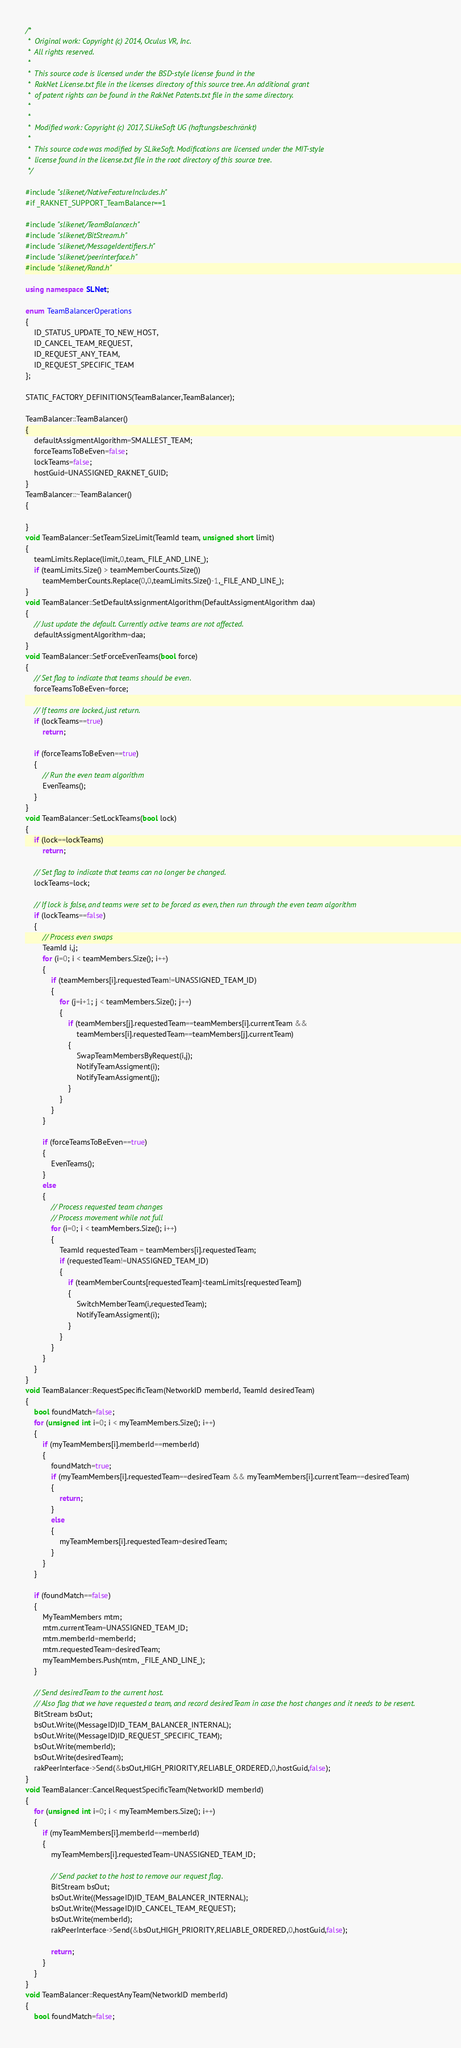<code> <loc_0><loc_0><loc_500><loc_500><_C++_>/*
 *  Original work: Copyright (c) 2014, Oculus VR, Inc.
 *  All rights reserved.
 *
 *  This source code is licensed under the BSD-style license found in the
 *  RakNet License.txt file in the licenses directory of this source tree. An additional grant 
 *  of patent rights can be found in the RakNet Patents.txt file in the same directory.
 *
 *
 *  Modified work: Copyright (c) 2017, SLikeSoft UG (haftungsbeschränkt)
 *
 *  This source code was modified by SLikeSoft. Modifications are licensed under the MIT-style
 *  license found in the license.txt file in the root directory of this source tree.
 */

#include "slikenet/NativeFeatureIncludes.h"
#if _RAKNET_SUPPORT_TeamBalancer==1

#include "slikenet/TeamBalancer.h"
#include "slikenet/BitStream.h"
#include "slikenet/MessageIdentifiers.h"
#include "slikenet/peerinterface.h"
#include "slikenet/Rand.h"

using namespace SLNet;

enum TeamBalancerOperations
{
	ID_STATUS_UPDATE_TO_NEW_HOST,
	ID_CANCEL_TEAM_REQUEST,
	ID_REQUEST_ANY_TEAM,
	ID_REQUEST_SPECIFIC_TEAM
};

STATIC_FACTORY_DEFINITIONS(TeamBalancer,TeamBalancer);

TeamBalancer::TeamBalancer()
{
	defaultAssigmentAlgorithm=SMALLEST_TEAM;
	forceTeamsToBeEven=false;
	lockTeams=false;
	hostGuid=UNASSIGNED_RAKNET_GUID;
}
TeamBalancer::~TeamBalancer()
{

}
void TeamBalancer::SetTeamSizeLimit(TeamId team, unsigned short limit)
{
	teamLimits.Replace(limit,0,team,_FILE_AND_LINE_);
	if (teamLimits.Size() > teamMemberCounts.Size())
		teamMemberCounts.Replace(0,0,teamLimits.Size()-1,_FILE_AND_LINE_);
}
void TeamBalancer::SetDefaultAssignmentAlgorithm(DefaultAssigmentAlgorithm daa)
{
	// Just update the default. Currently active teams are not affected.
	defaultAssigmentAlgorithm=daa;
}
void TeamBalancer::SetForceEvenTeams(bool force)
{
	// Set flag to indicate that teams should be even.
	forceTeamsToBeEven=force;

	// If teams are locked, just return.
	if (lockTeams==true)
		return;

	if (forceTeamsToBeEven==true)
	{
		// Run the even team algorithm
		EvenTeams();
	}
}
void TeamBalancer::SetLockTeams(bool lock)
{
	if (lock==lockTeams)
		return;

	// Set flag to indicate that teams can no longer be changed.
	lockTeams=lock;

	// If lock is false, and teams were set to be forced as even, then run through the even team algorithm
	if (lockTeams==false)
	{
		// Process even swaps
		TeamId i,j;
		for (i=0; i < teamMembers.Size(); i++)
		{
			if (teamMembers[i].requestedTeam!=UNASSIGNED_TEAM_ID)
			{
				for (j=i+1; j < teamMembers.Size(); j++)
				{
					if (teamMembers[j].requestedTeam==teamMembers[i].currentTeam &&
						teamMembers[i].requestedTeam==teamMembers[j].currentTeam)
					{
						SwapTeamMembersByRequest(i,j);
						NotifyTeamAssigment(i);
						NotifyTeamAssigment(j);
					}
				}
			}
		}

		if (forceTeamsToBeEven==true)
		{
			EvenTeams();
		}
		else
		{
			// Process requested team changes
			// Process movement while not full
			for (i=0; i < teamMembers.Size(); i++)
			{
				TeamId requestedTeam = teamMembers[i].requestedTeam;
				if (requestedTeam!=UNASSIGNED_TEAM_ID)
				{
					if (teamMemberCounts[requestedTeam]<teamLimits[requestedTeam])
					{
						SwitchMemberTeam(i,requestedTeam);
						NotifyTeamAssigment(i);
					}
				}
			}
		}
	}
}
void TeamBalancer::RequestSpecificTeam(NetworkID memberId, TeamId desiredTeam)
{
	bool foundMatch=false;
	for (unsigned int i=0; i < myTeamMembers.Size(); i++)
	{
		if (myTeamMembers[i].memberId==memberId)
		{
			foundMatch=true;
			if (myTeamMembers[i].requestedTeam==desiredTeam && myTeamMembers[i].currentTeam==desiredTeam)
			{
				return;
			}
			else
			{
				myTeamMembers[i].requestedTeam=desiredTeam;
			}
		}
	}

	if (foundMatch==false)
	{
		MyTeamMembers mtm;
		mtm.currentTeam=UNASSIGNED_TEAM_ID;
		mtm.memberId=memberId;
		mtm.requestedTeam=desiredTeam;
		myTeamMembers.Push(mtm, _FILE_AND_LINE_);
	}

	// Send desiredTeam to the current host.
	// Also flag that we have requested a team, and record desiredTeam in case the host changes and it needs to be resent.
	BitStream bsOut;
	bsOut.Write((MessageID)ID_TEAM_BALANCER_INTERNAL);
	bsOut.Write((MessageID)ID_REQUEST_SPECIFIC_TEAM);
	bsOut.Write(memberId);
	bsOut.Write(desiredTeam);
	rakPeerInterface->Send(&bsOut,HIGH_PRIORITY,RELIABLE_ORDERED,0,hostGuid,false);
}
void TeamBalancer::CancelRequestSpecificTeam(NetworkID memberId)
{
	for (unsigned int i=0; i < myTeamMembers.Size(); i++)
	{
		if (myTeamMembers[i].memberId==memberId)
		{
			myTeamMembers[i].requestedTeam=UNASSIGNED_TEAM_ID;

			// Send packet to the host to remove our request flag.
			BitStream bsOut;
			bsOut.Write((MessageID)ID_TEAM_BALANCER_INTERNAL);
			bsOut.Write((MessageID)ID_CANCEL_TEAM_REQUEST);
			bsOut.Write(memberId);
			rakPeerInterface->Send(&bsOut,HIGH_PRIORITY,RELIABLE_ORDERED,0,hostGuid,false);

			return;
		}
	}
}
void TeamBalancer::RequestAnyTeam(NetworkID memberId)
{
	bool foundMatch=false;
</code> 